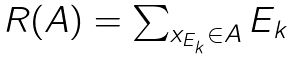Convert formula to latex. <formula><loc_0><loc_0><loc_500><loc_500>\begin{array} { l } R ( A ) = \sum _ { x _ { E _ { k } } \in A } E _ { k } \end{array}</formula> 